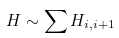Convert formula to latex. <formula><loc_0><loc_0><loc_500><loc_500>H \sim \sum H _ { i , i + 1 }</formula> 